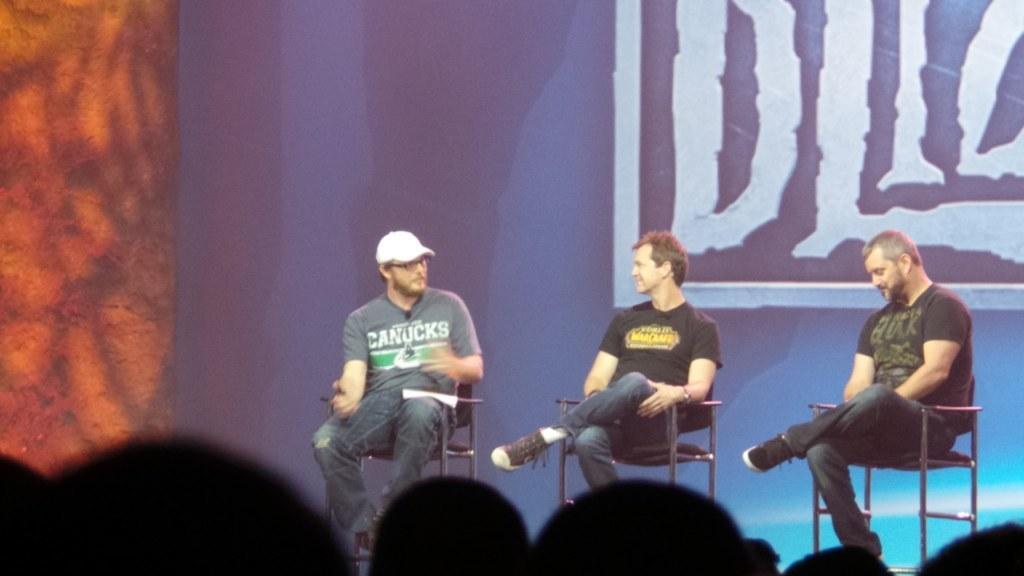In one or two sentences, can you explain what this image depicts? In this image I see 3 men over here who are sitting on chairs and I see that this man is wearing a white cap and I see the background which is colorful and I see it is black over here. 